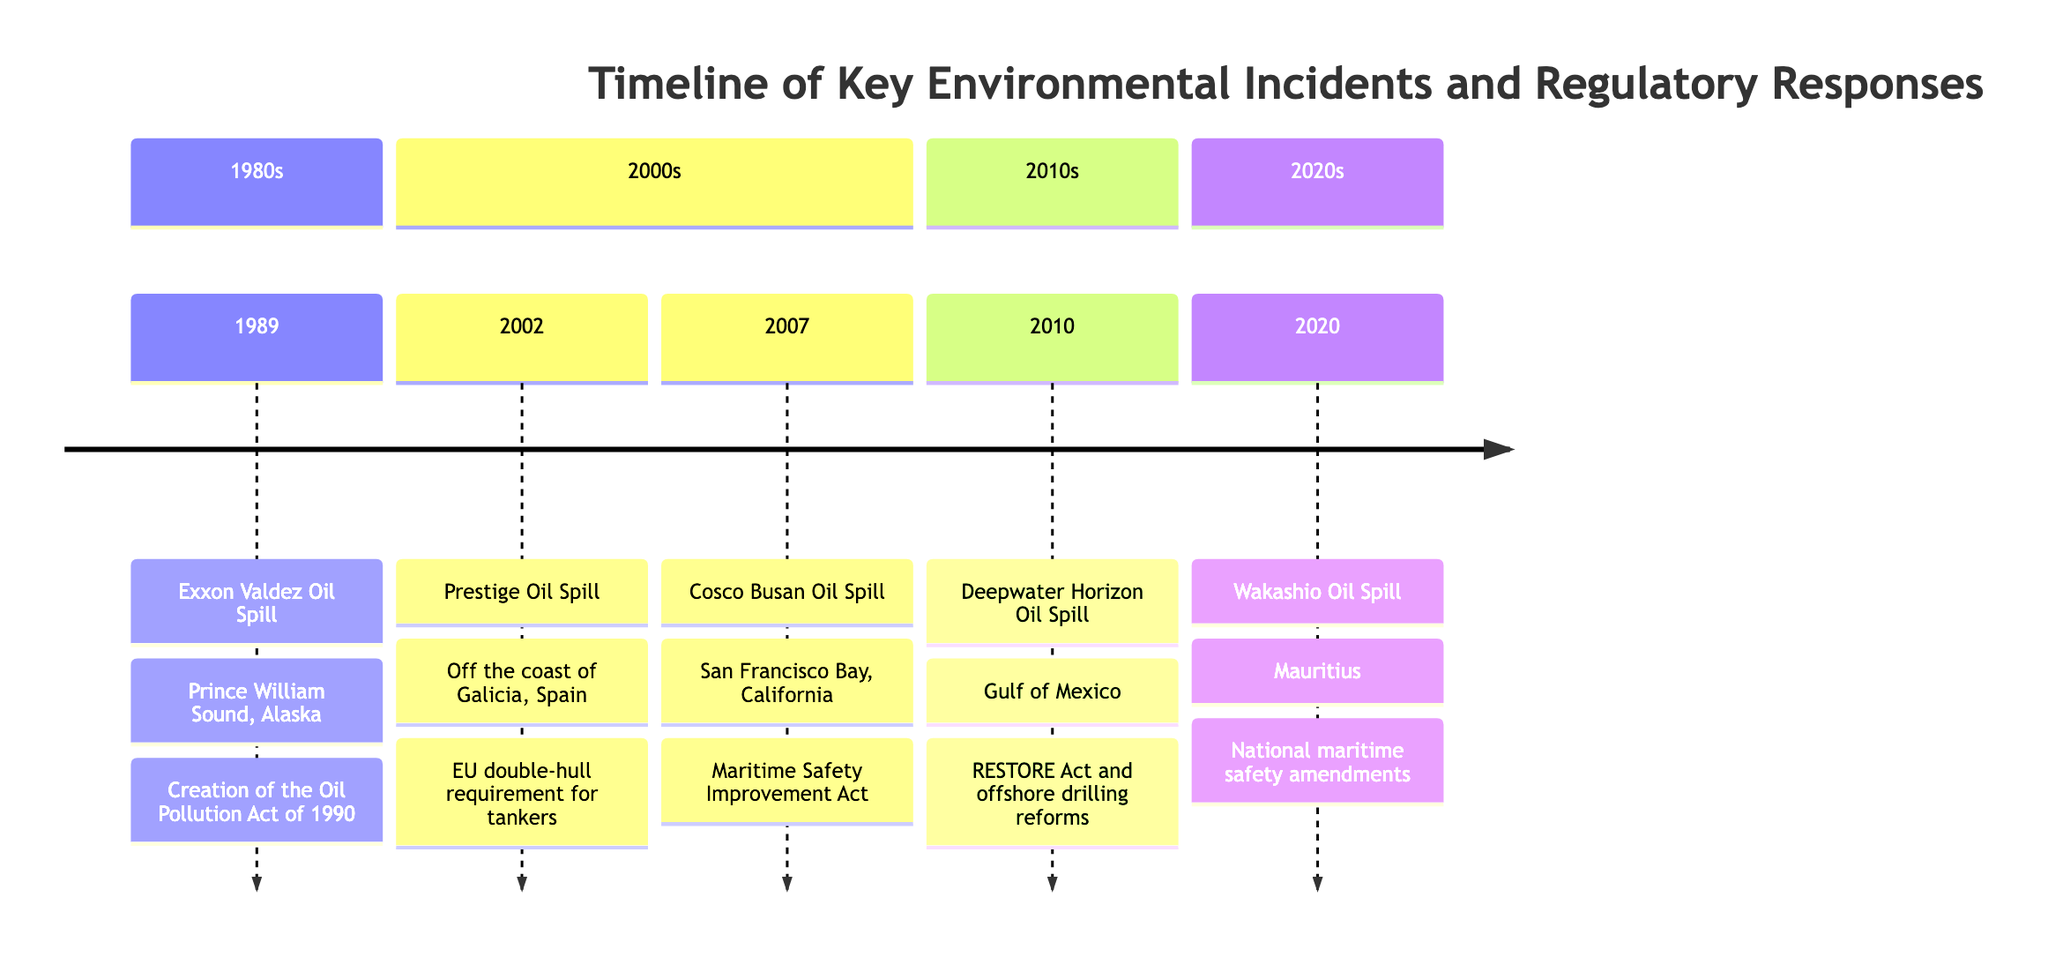What year did the Exxon Valdez Oil Spill occur? The diagram indicates that the Exxon Valdez Oil Spill took place in 1989. This information is located in the year section of the timeline for the incident.
Answer: 1989 What incident occurred in the Gulf of Mexico? Looking at the timeline, the incident specified for the Gulf of Mexico is the Deepwater Horizon Oil Spill, which is listed under the 2010s section.
Answer: Deepwater Horizon Oil Spill What regulatory response was created in response to the Exxon Valdez Oil Spill? The timeline shows that in response to the Exxon Valdez Oil Spill, the regulatory response was the creation of the Oil Pollution Act of 1990. This is directly mentioned right after the incident description.
Answer: Creation of the Oil Pollution Act of 1990 How many incidents are listed in the 2000s section of the diagram? In the 2000s section of the timeline, there are two incidents listed: the Prestige Oil Spill in 2002 and the Cosco Busan Oil Spill in 2007. By counting these two, we identify the total for that section.
Answer: 2 What was the location of the Wakashio Oil Spill? The diagram specifies that the Wakashio Oil Spill took place in Mauritius. This information is explicitly provided in the description of the incident on the timeline.
Answer: Mauritius Which incident led to the implementation of the RESTORE Act? According to the timeline, the Deepwater Horizon Oil Spill led to the implementation of the RESTORE Act as a part of the regulatory response in 2010. This connects the incident to its regulatory outcome.
Answer: Deepwater Horizon Oil Spill What does the timeline show about the regulatory response to the Prestige Oil Spill? The timeline indicates that the regulatory response to the Prestige Oil Spill was the introduction of the European Union’s double-hull requirement for tankers. This connects the incident with its specific regulatory outcome.
Answer: EU double-hull requirement for tankers Which incident has the most recent regulatory response listed? Analyzing the timeline, the most recent incident is the Wakashio Oil Spill in 2020, which is associated with national maritime safety amendments. This defines the relationship between incident and regulatory timeline.
Answer: Wakashio Oil Spill 